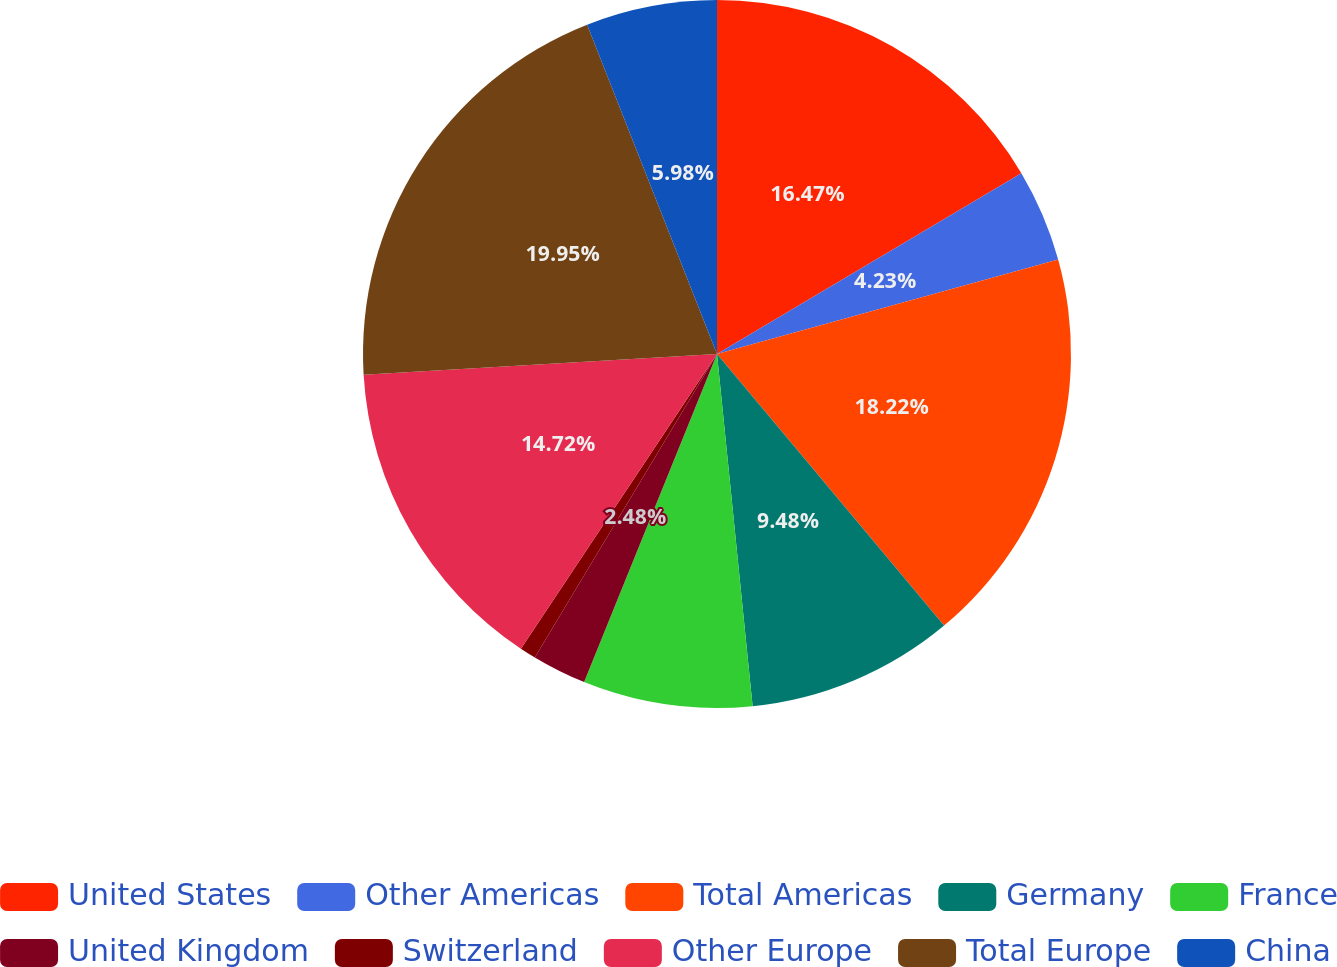<chart> <loc_0><loc_0><loc_500><loc_500><pie_chart><fcel>United States<fcel>Other Americas<fcel>Total Americas<fcel>Germany<fcel>France<fcel>United Kingdom<fcel>Switzerland<fcel>Other Europe<fcel>Total Europe<fcel>China<nl><fcel>16.47%<fcel>4.23%<fcel>18.22%<fcel>9.48%<fcel>7.73%<fcel>2.48%<fcel>0.74%<fcel>14.72%<fcel>19.96%<fcel>5.98%<nl></chart> 